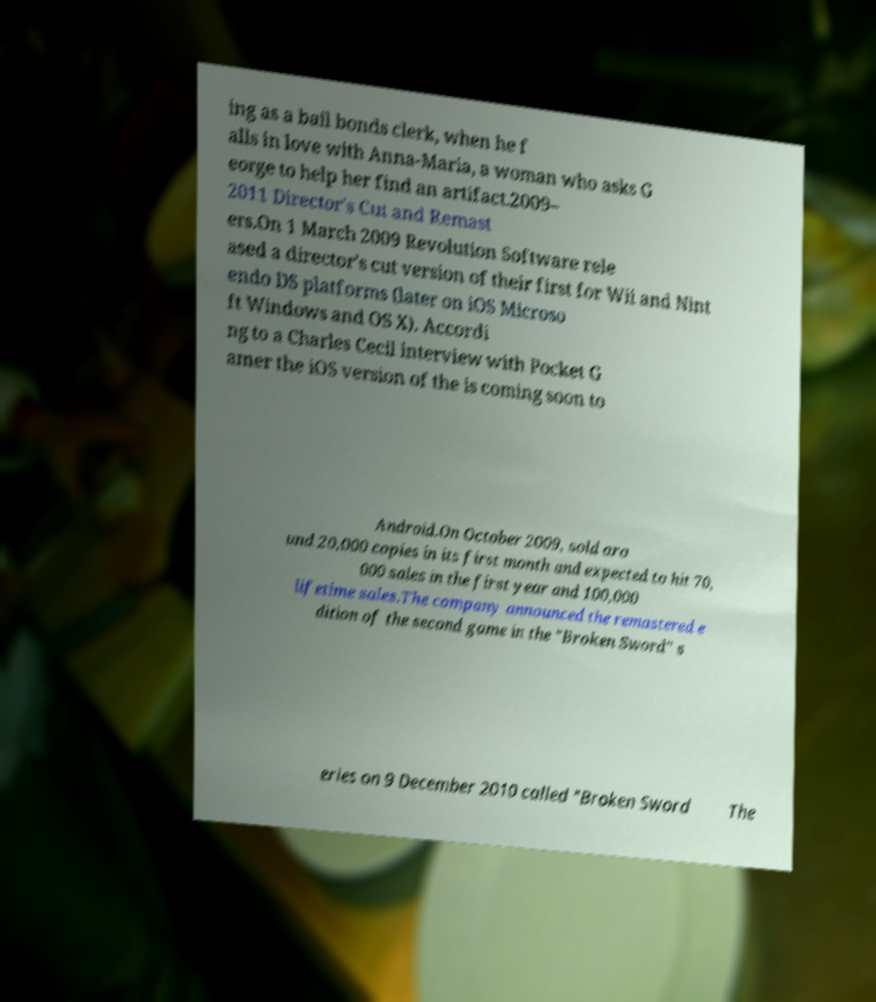Could you assist in decoding the text presented in this image and type it out clearly? ing as a bail bonds clerk, when he f alls in love with Anna-Maria, a woman who asks G eorge to help her find an artifact.2009– 2011 Director's Cut and Remast ers.On 1 March 2009 Revolution Software rele ased a director's cut version of their first for Wii and Nint endo DS platforms (later on iOS Microso ft Windows and OS X). Accordi ng to a Charles Cecil interview with Pocket G amer the iOS version of the is coming soon to Android.On October 2009, sold aro und 20,000 copies in its first month and expected to hit 70, 000 sales in the first year and 100,000 lifetime sales.The company announced the remastered e dition of the second game in the "Broken Sword" s eries on 9 December 2010 called "Broken Sword The 